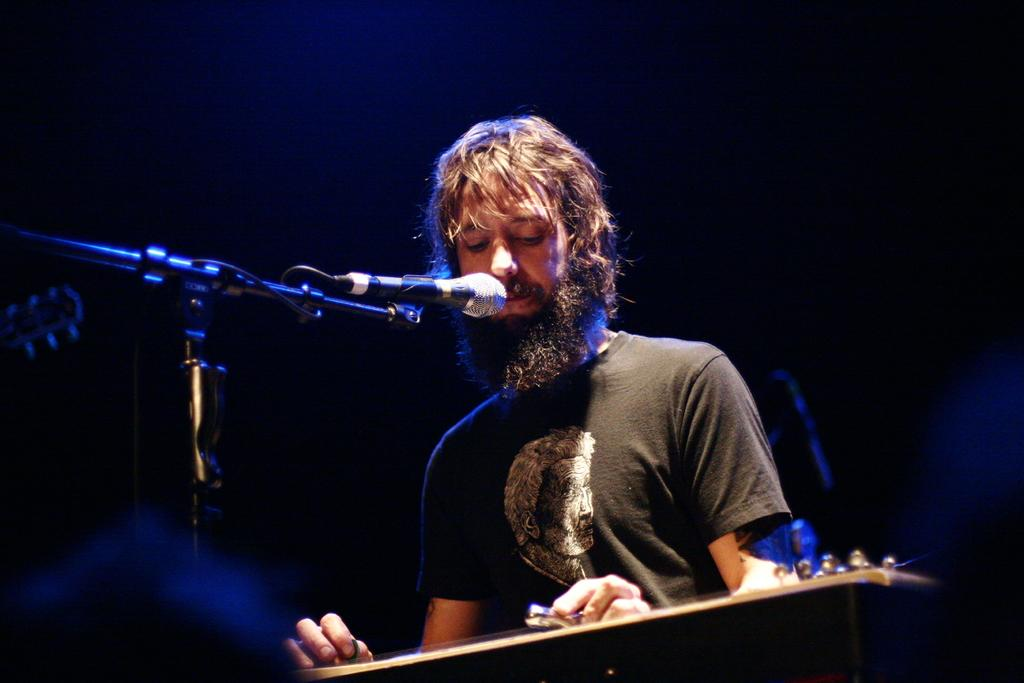Who is the main subject in the image? There is a man in the image. What is the man doing in the image? The man is playing the guitar. What object is in front of the man? There is a microphone in front of the man. What type of trick does the man perform with the sidewalk in the image? There is no sidewalk present in the image, and therefore no trick involving a sidewalk can be observed. 